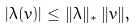Convert formula to latex. <formula><loc_0><loc_0><loc_500><loc_500>| \lambda ( v ) | \leq \| \lambda \| _ { * } \, \| v \| ,</formula> 